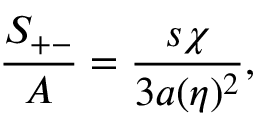Convert formula to latex. <formula><loc_0><loc_0><loc_500><loc_500>{ \frac { S _ { + - } } { A } } = { \frac { s \chi } { 3 a ( \eta ) ^ { 2 } } } ,</formula> 